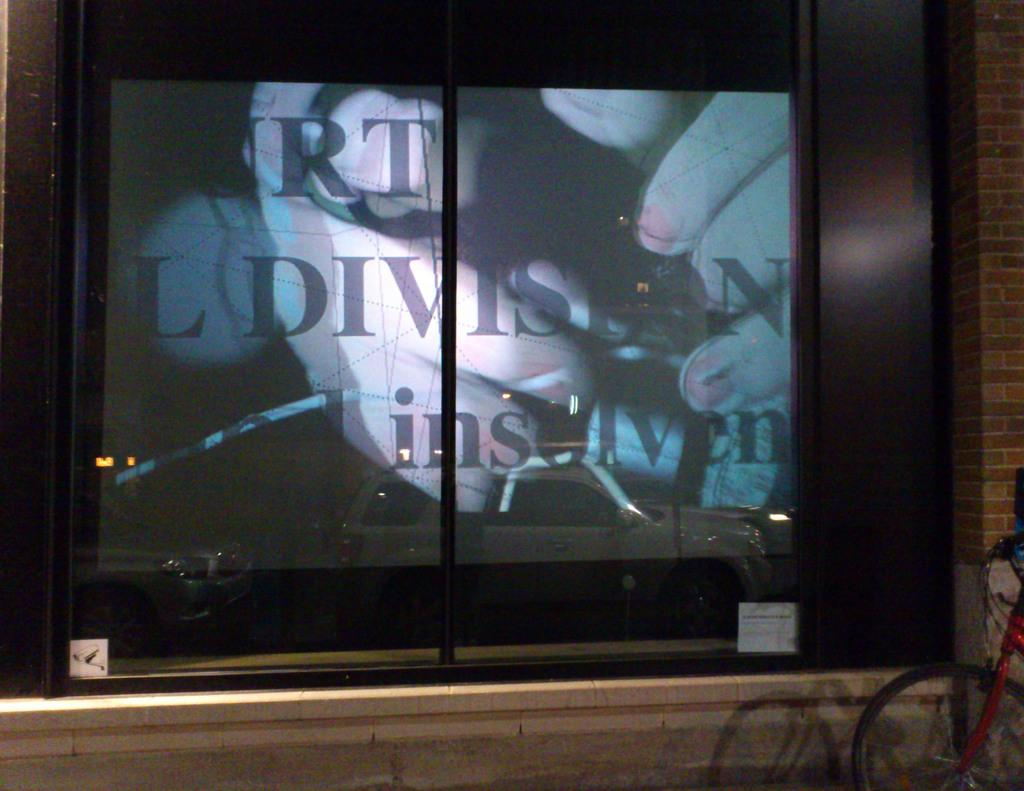<image>
Relay a brief, clear account of the picture shown. A TV is behind a glass case in the wall and it says Urt L Division on the screen. 